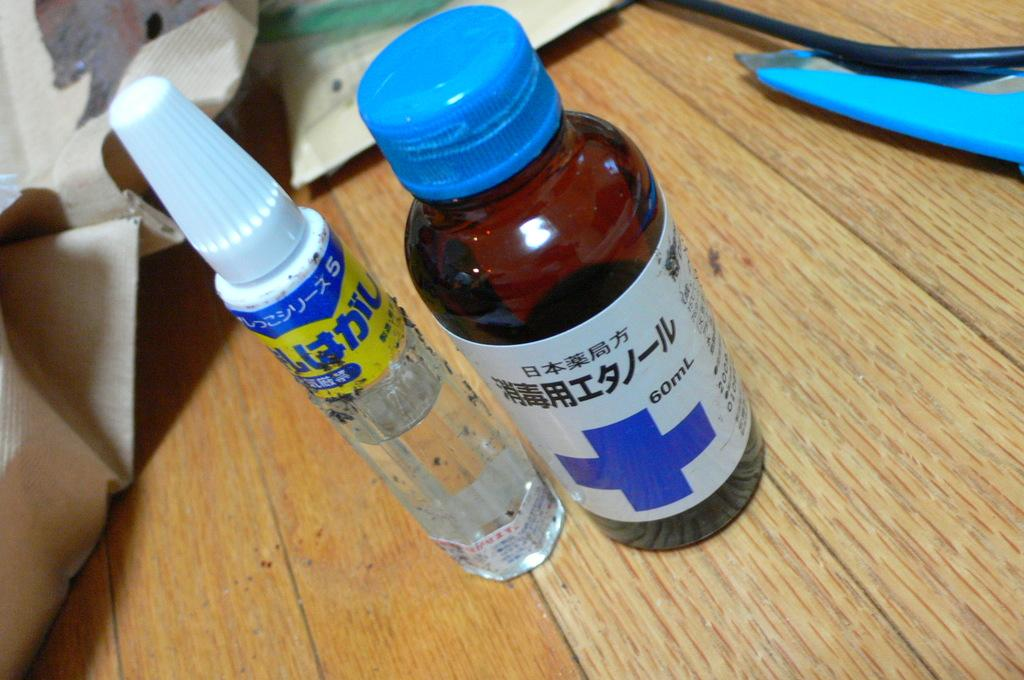<image>
Summarize the visual content of the image. A 60mL dark brown bottle with a blue cross on it sits on the desk. 